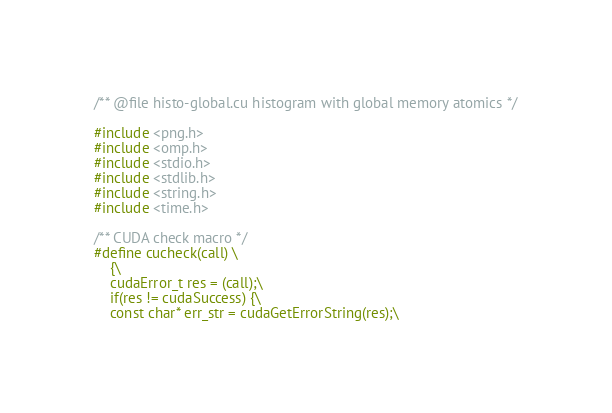Convert code to text. <code><loc_0><loc_0><loc_500><loc_500><_Cuda_>/** @file histo-global.cu histogram with global memory atomics */

#include <png.h>
#include <omp.h>
#include <stdio.h>
#include <stdlib.h>
#include <string.h>
#include <time.h>

/** CUDA check macro */
#define cucheck(call) \
	{\
	cudaError_t res = (call);\
	if(res != cudaSuccess) {\
	const char* err_str = cudaGetErrorString(res);\</code> 